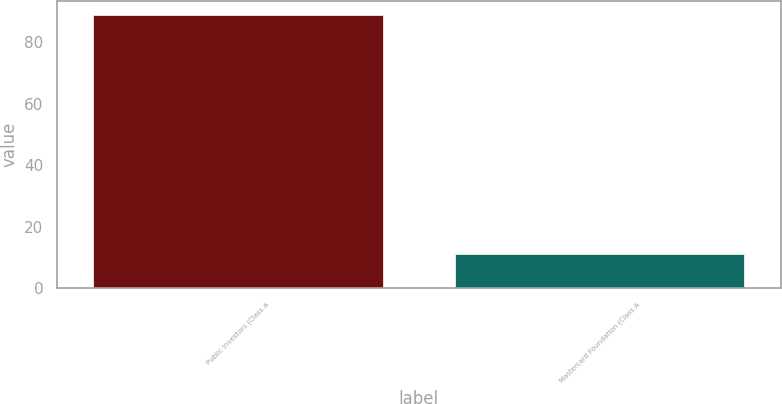<chart> <loc_0><loc_0><loc_500><loc_500><bar_chart><fcel>Public Investors (Class A<fcel>Mastercard Foundation (Class A<nl><fcel>89<fcel>11<nl></chart> 